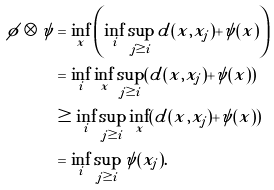Convert formula to latex. <formula><loc_0><loc_0><loc_500><loc_500>\phi \otimes \psi & = \inf _ { x } \left ( \inf _ { i } \sup _ { j \geq i } d ( x , x _ { j } ) + \psi ( x ) \right ) \\ & = \inf _ { i } \inf _ { x } \sup _ { j \geq i } ( d ( x , x _ { j } ) + \psi ( x ) ) \\ & \geq \inf _ { i } \sup _ { j \geq i } \inf _ { x } ( d ( x , x _ { j } ) + \psi ( x ) ) \\ & = \inf _ { i } \sup _ { j \geq i } \psi ( x _ { j } ) .</formula> 